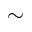Convert formula to latex. <formula><loc_0><loc_0><loc_500><loc_500>\sim</formula> 